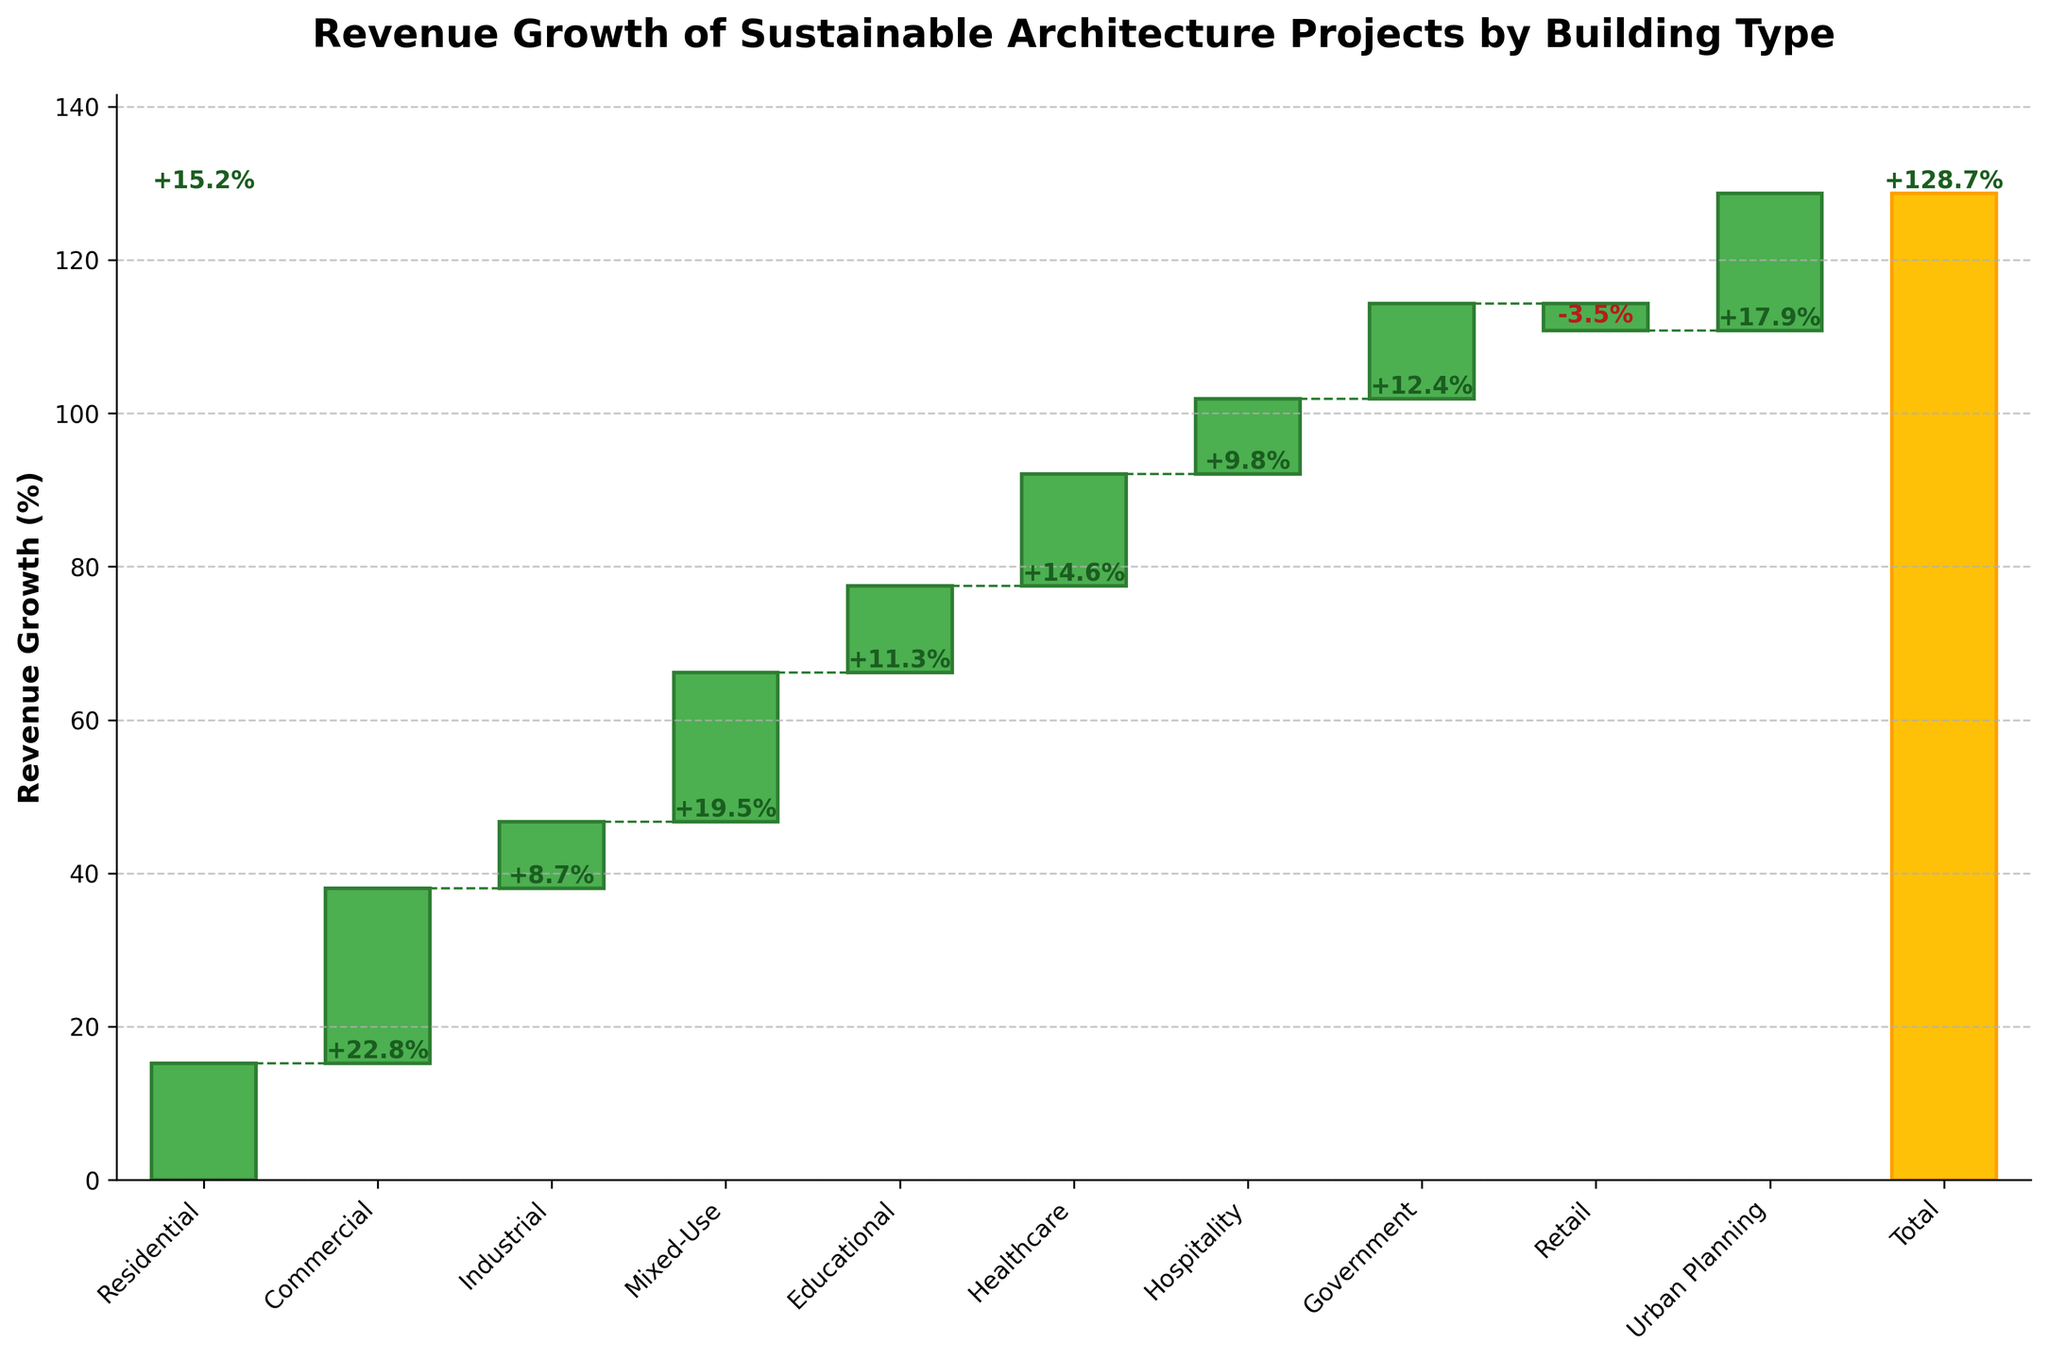What's the title of the chart? The title is prominently placed at the top of the chart and should provide a summary of what the chart is about. The title in this case is "Revenue Growth of Sustainable Architecture Projects by Building Type".
Answer: Revenue Growth of Sustainable Architecture Projects by Building Type What is the revenue growth percentage for residential buildings? Locate the bar labeled "Residential" on the x-axis of the chart. The value label on that bar shows the revenue growth percentage.
Answer: 15.2% Which building type has the highest revenue growth percentage? Compare the values of all the bars representing different building types. The bar with the highest value is the one corresponding to "Commercial".
Answer: Commercial What is the total revenue growth percentage? The bar labeled "Total" at the far right of the chart represents the sum of all other values. The value label shows the total percentage.
Answer: 128.7% How does the revenue growth for healthcare compare to educational buildings? Locate the bars for "Healthcare" and "Educational". Compare their values: Healthcare has 14.6% and Educational has 11.3%. Thus, Healthcare is higher.
Answer: Healthcare is higher Which building type has a negative revenue growth percentage? Identify the bar with a negative value. In this chart, "Retail" has a negative growth percentage, as indicated by a bar going downward.
Answer: Retail What is the combined revenue growth percentage for Industrial and Hospitality buildings? Find the values for "Industrial" and "Hospitality". Add them together: 8.7% + 9.8% = 18.5%.
Answer: 18.5% How does the revenue growth of Urban Planning compare to Mixed-Use buildings? Locate the bars for "Urban Planning" and "Mixed-Use". Compare their values: Urban Planning has 17.9%, and Mixed-Use has 19.5%. Thus, Mixed-Use is higher but only by a small margin.
Answer: Mixed-Use is higher What is the second highest revenue growth percentage after Commercial buildings? First, identify the highest value, which is Commercial at 22.8%. Next, identify the second highest which is Mixed-Use at 19.5%.
Answer: Mixed-Use, 19.5% If you exclude the Retail category, what would be the revised total revenue growth percentage? Exclude the negative contribution of "Retail" (-3.5%) from the current total of 128.7%. Add 3.5 to 128.7 to get the revised total. 128.7% + 3.5% = 132.2%.
Answer: 132.2% 